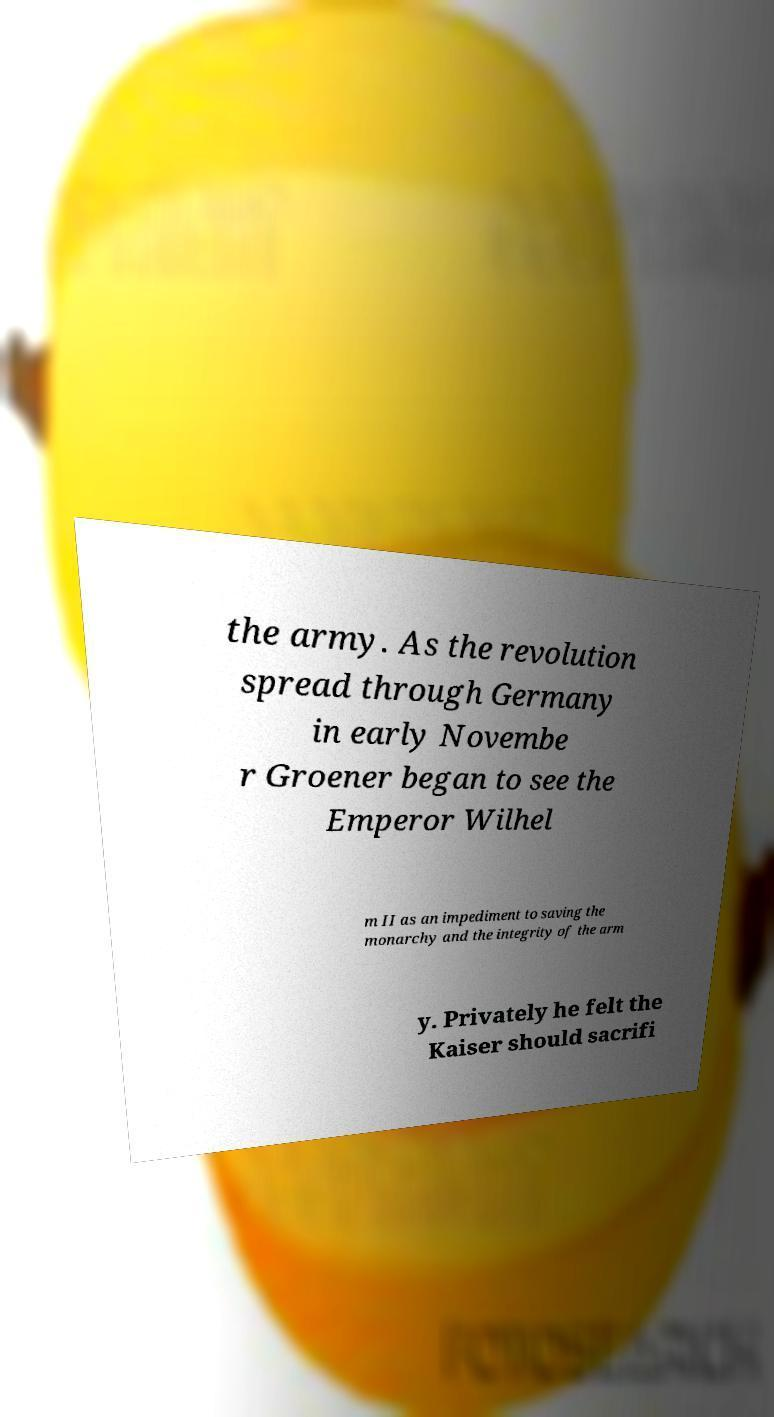Can you accurately transcribe the text from the provided image for me? the army. As the revolution spread through Germany in early Novembe r Groener began to see the Emperor Wilhel m II as an impediment to saving the monarchy and the integrity of the arm y. Privately he felt the Kaiser should sacrifi 